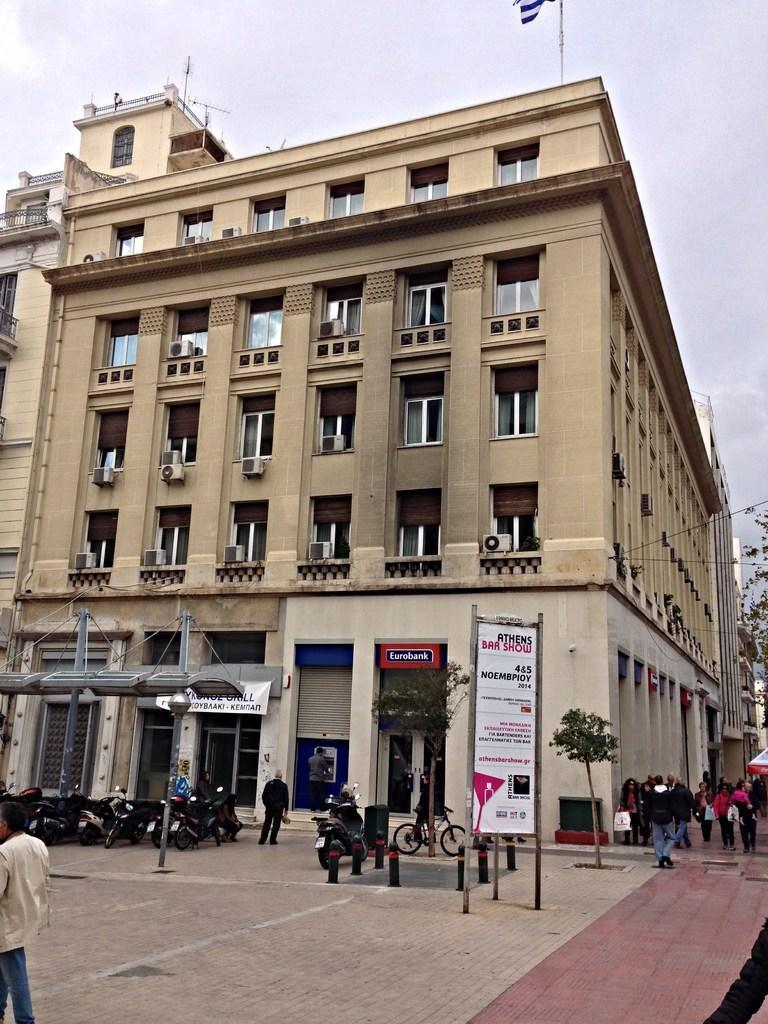Could you give a brief overview of what you see in this image? In this image we can see a building. On the building we can see windows, air conditioners and a board with text. In front of the building we can see vehicles, trees, poles, persons and a board with text. On the right side, we can see the persons and the trees. There is a flag on the building. At the top we can see the sky. 